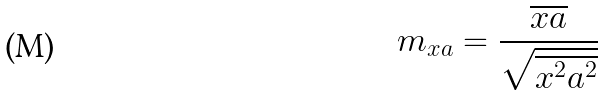Convert formula to latex. <formula><loc_0><loc_0><loc_500><loc_500>m _ { x a } = \frac { \overline { x a } } { \sqrt { \overline { x ^ { 2 } } \overline { a ^ { 2 } } } }</formula> 